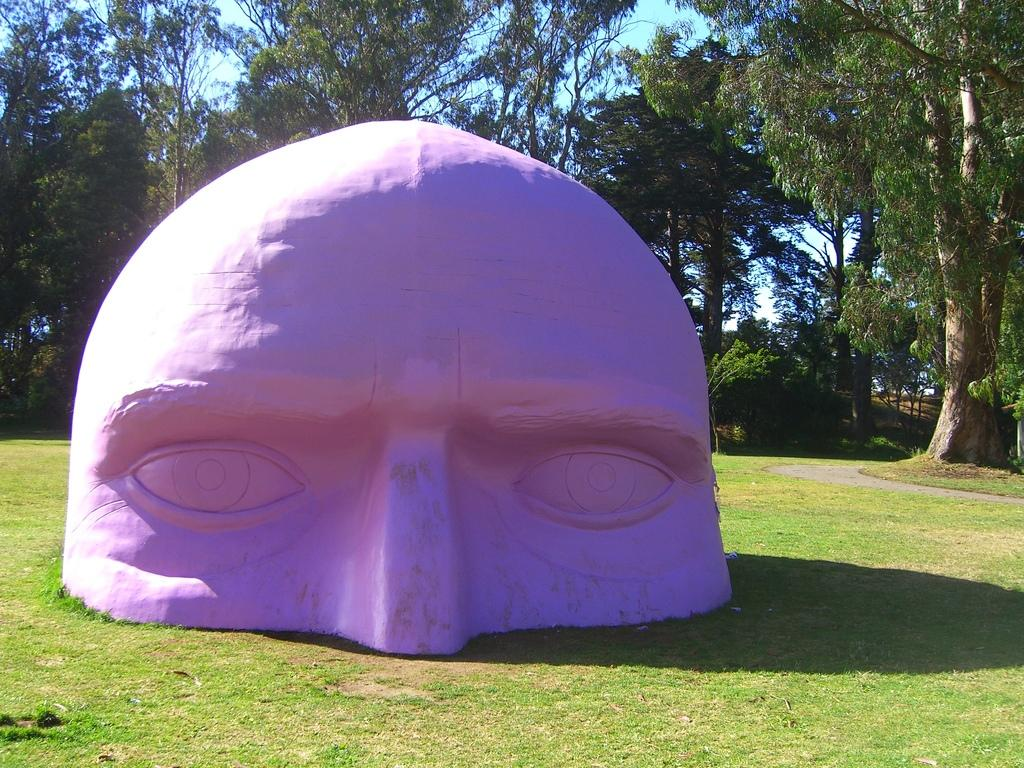What type of natural vegetation can be seen in the image? There are trees in the image. What part of the natural environment is visible in the image? The sky is visible in the image. Can you describe the color of any objects in the image? There is a purple color object in the image. What is the purpose of the scale in the image? There is no scale present in the image. 